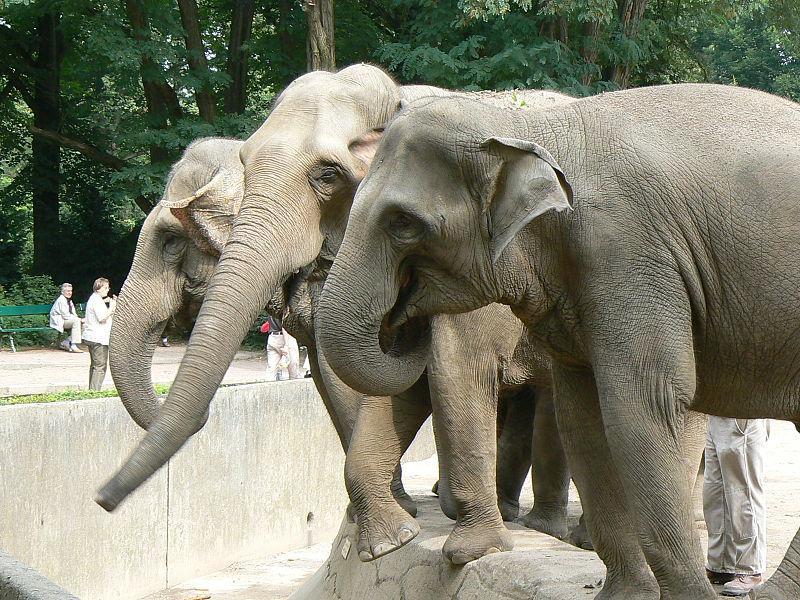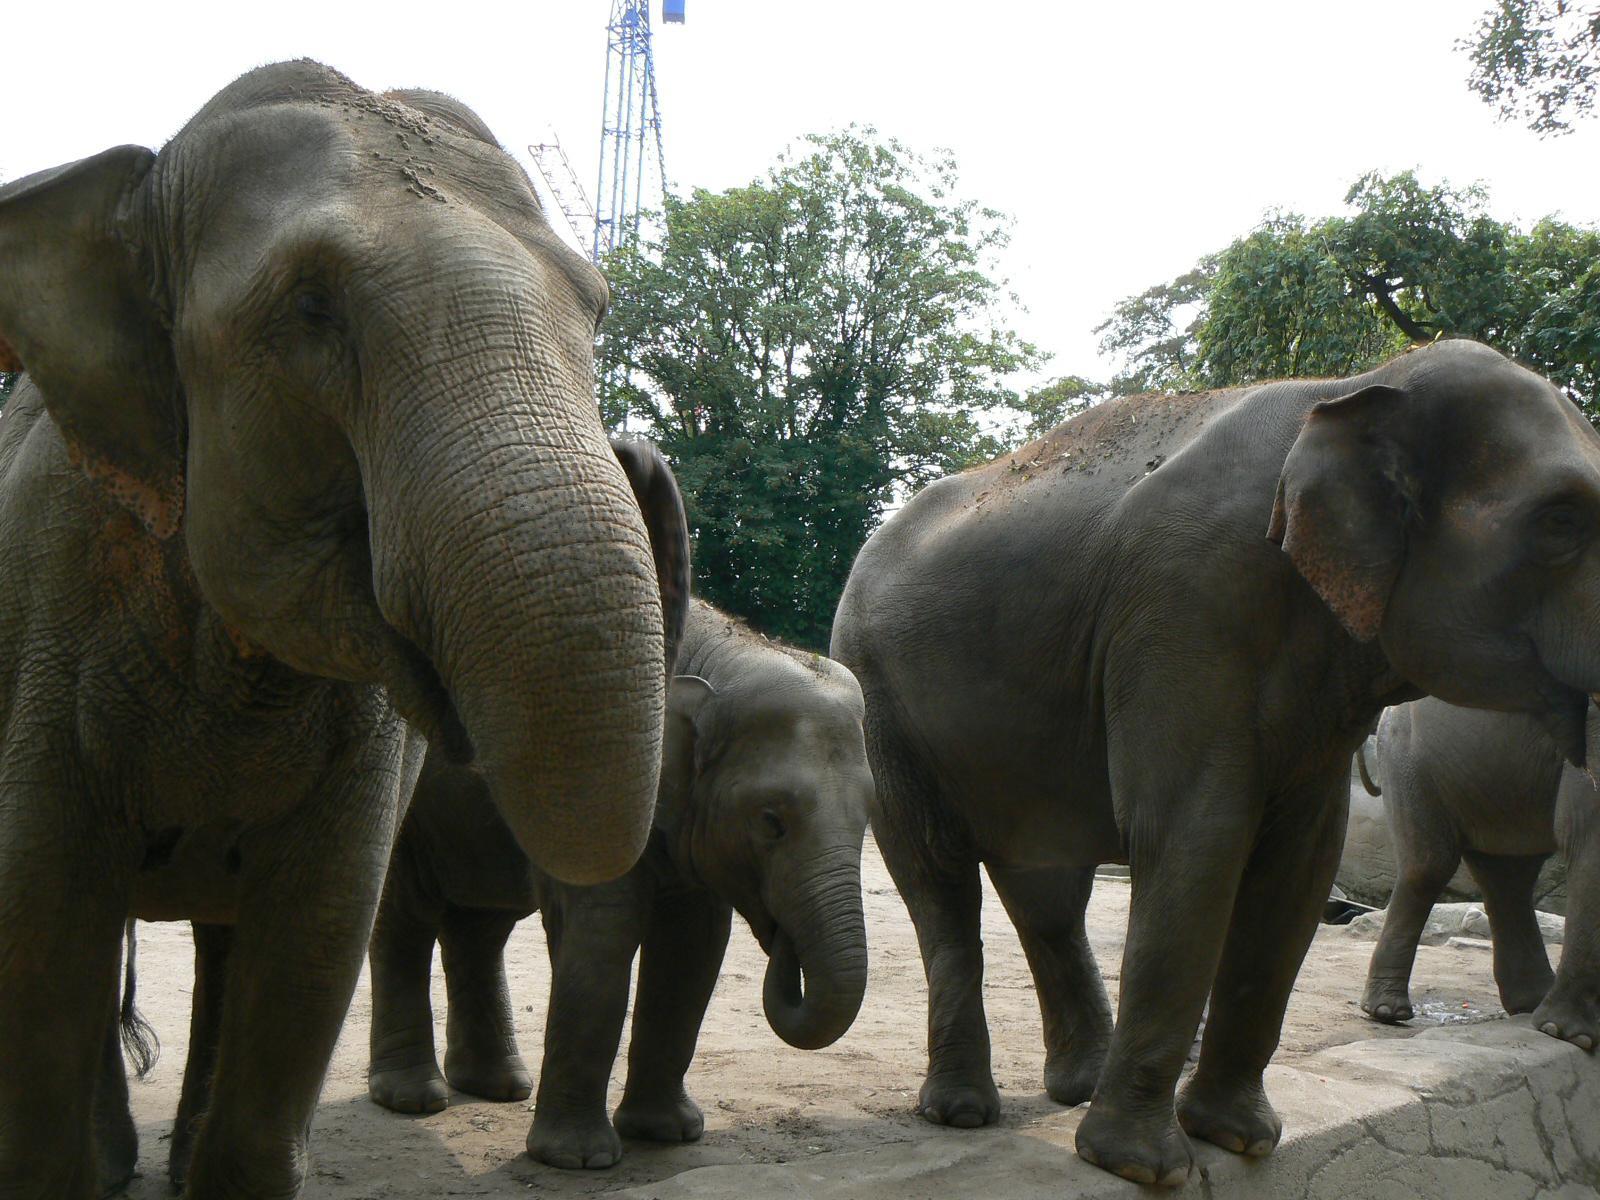The first image is the image on the left, the second image is the image on the right. For the images shown, is this caption "An image includes exactly one elephant, which has an upraised, curled trunk." true? Answer yes or no. No. The first image is the image on the left, the second image is the image on the right. Evaluate the accuracy of this statement regarding the images: "A single elephant is standing in one of the images.". Is it true? Answer yes or no. No. 